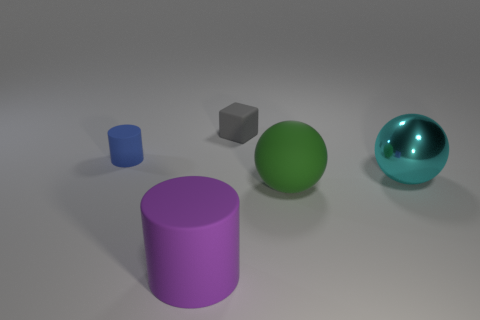Add 4 small gray rubber blocks. How many objects exist? 9 Subtract all cubes. How many objects are left? 4 Add 5 tiny blue matte objects. How many tiny blue matte objects are left? 6 Add 4 small rubber cubes. How many small rubber cubes exist? 5 Subtract 0 cyan cubes. How many objects are left? 5 Subtract all green metal spheres. Subtract all big purple matte cylinders. How many objects are left? 4 